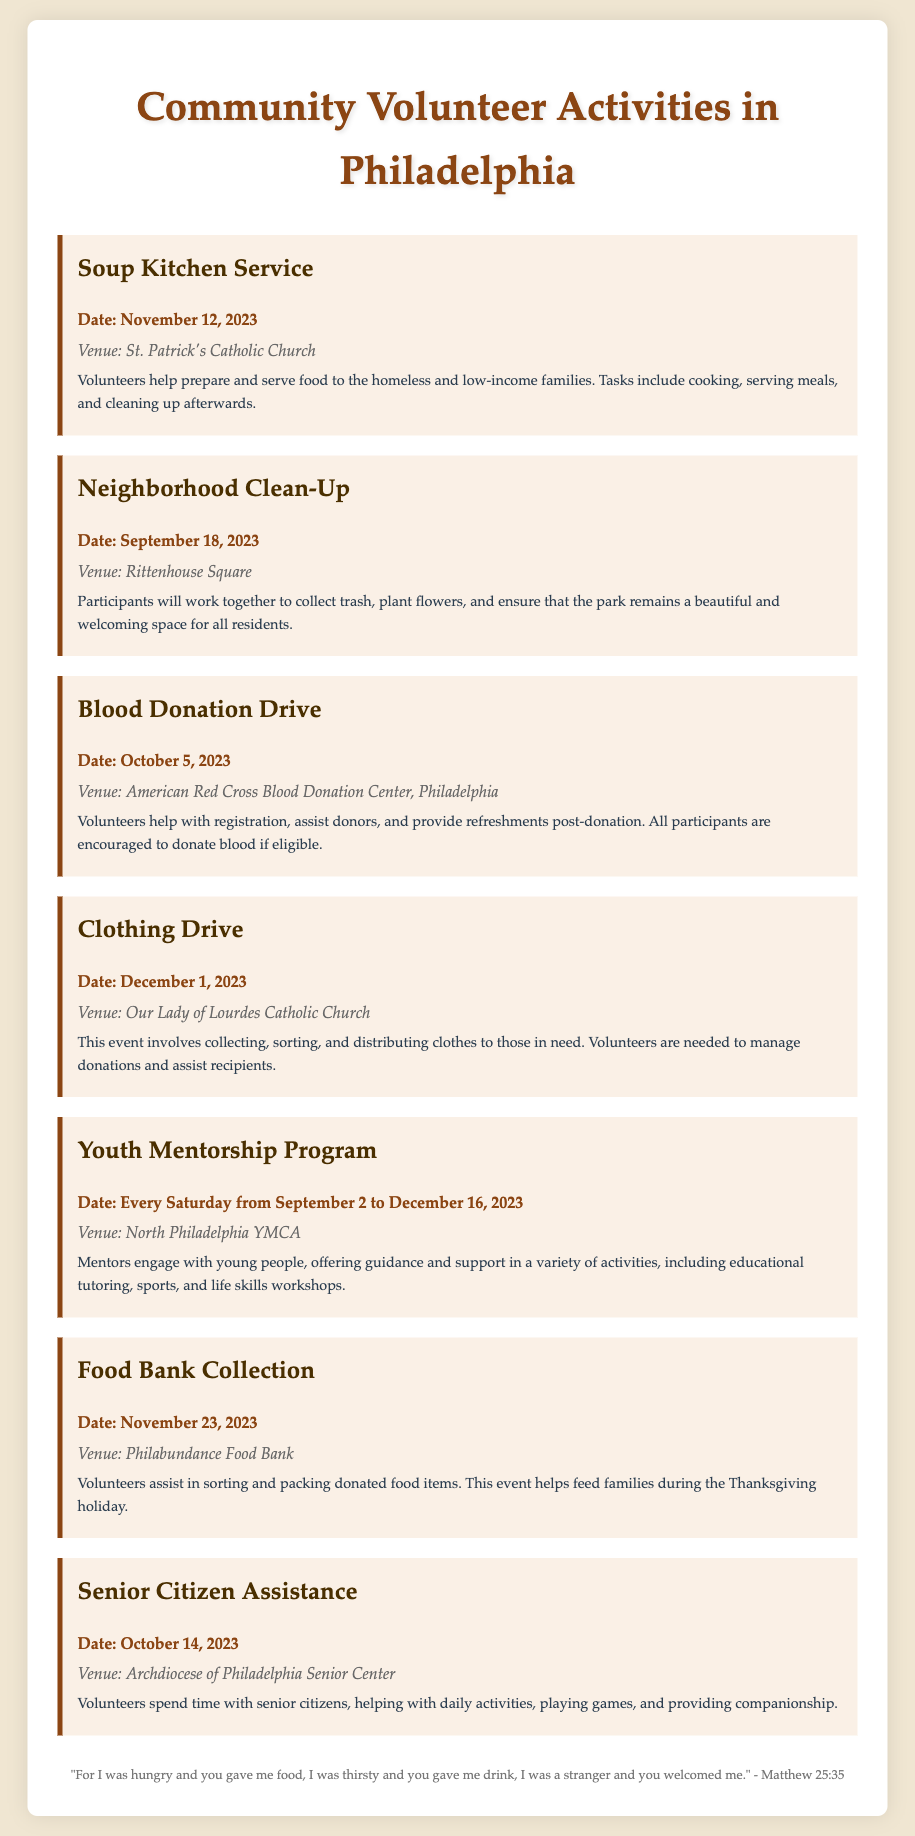What is the date for the Soup Kitchen Service? The date is provided in the description of the Soup Kitchen Service activity.
Answer: November 12, 2023 Where is the Blood Donation Drive taking place? The venue is mentioned in the details of the Blood Donation Drive activity.
Answer: American Red Cross Blood Donation Center, Philadelphia How often does the Youth Mentorship Program occur? The frequency is specified in the description of the Youth Mentorship Program.
Answer: Every Saturday What is the main task for volunteers during the Clothing Drive? The main task is highlighted in the details section of the Clothing Drive activity.
Answer: Collecting, sorting, and distributing clothes When is the Food Bank Collection event? The date for the Food Bank Collection is listed in the activity description.
Answer: November 23, 2023 What type of assistance is offered to senior citizens? The type of assistance is detailed in the description of the Senior Citizen Assistance activity.
Answer: Daily activities and companionship Which venue hosts the Neighborhood Clean-Up? The venue information is clearly stated under the Neighborhood Clean-Up activity.
Answer: Rittenhouse Square How many activities are mentioned in the document? The number of activities can be counted from the list provided.
Answer: Seven 